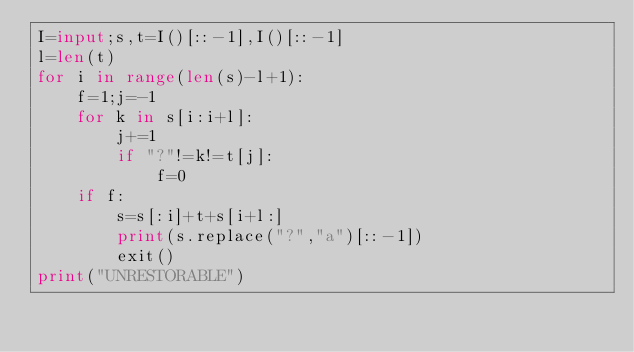Convert code to text. <code><loc_0><loc_0><loc_500><loc_500><_Python_>I=input;s,t=I()[::-1],I()[::-1]
l=len(t)
for i in range(len(s)-l+1):
	f=1;j=-1
	for k in s[i:i+l]:
		j+=1
		if "?"!=k!=t[j]:
			f=0
	if f:
		s=s[:i]+t+s[i+l:]
		print(s.replace("?","a")[::-1])
		exit()
print("UNRESTORABLE")</code> 